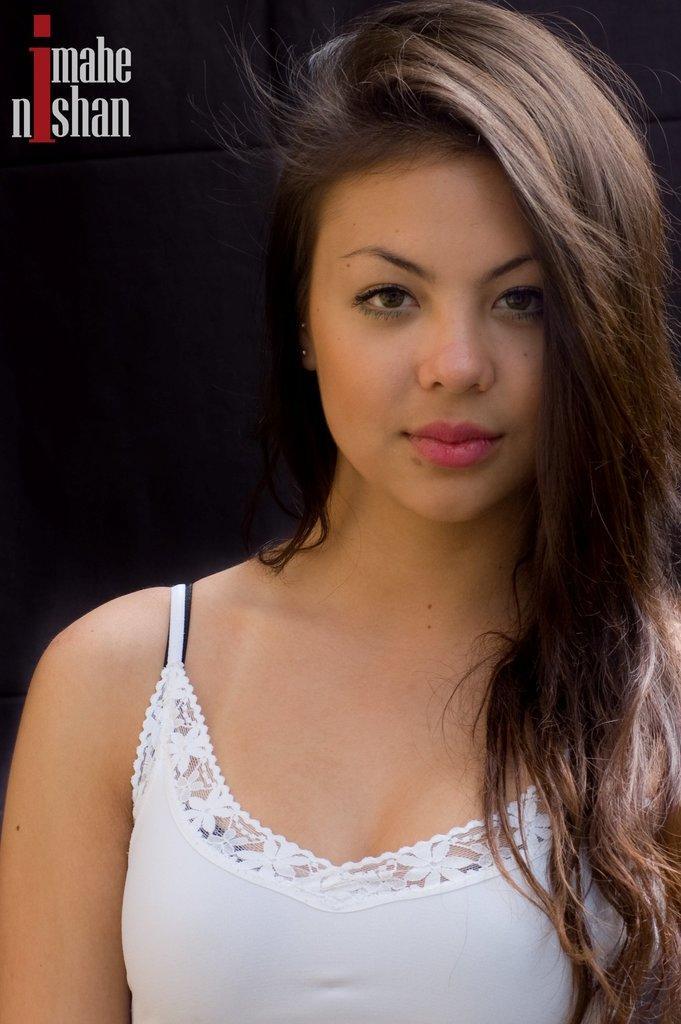Describe this image in one or two sentences. In this image we can see a lady posing for a picture and on the top left corner of the image there is some text. 